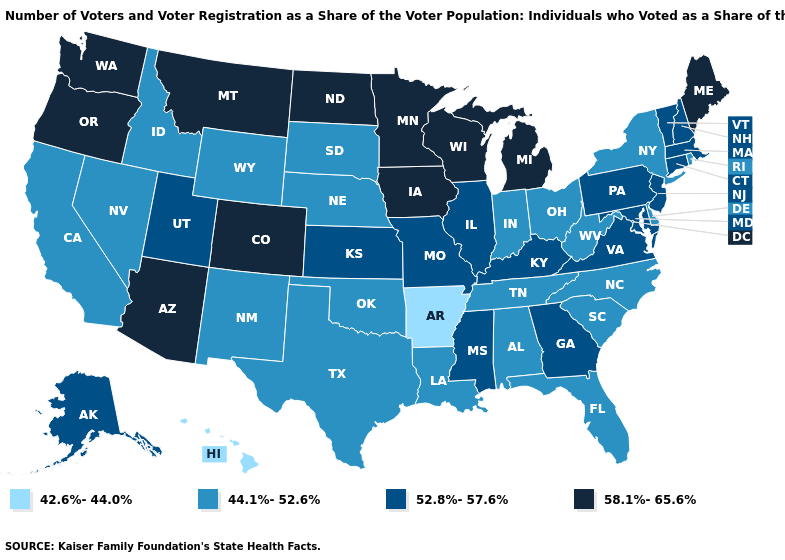What is the value of Pennsylvania?
Keep it brief. 52.8%-57.6%. Does Rhode Island have the same value as New Mexico?
Be succinct. Yes. Does Colorado have a lower value than Nevada?
Short answer required. No. Name the states that have a value in the range 52.8%-57.6%?
Quick response, please. Alaska, Connecticut, Georgia, Illinois, Kansas, Kentucky, Maryland, Massachusetts, Mississippi, Missouri, New Hampshire, New Jersey, Pennsylvania, Utah, Vermont, Virginia. Among the states that border Georgia , which have the lowest value?
Be succinct. Alabama, Florida, North Carolina, South Carolina, Tennessee. Which states have the highest value in the USA?
Be succinct. Arizona, Colorado, Iowa, Maine, Michigan, Minnesota, Montana, North Dakota, Oregon, Washington, Wisconsin. Name the states that have a value in the range 58.1%-65.6%?
Keep it brief. Arizona, Colorado, Iowa, Maine, Michigan, Minnesota, Montana, North Dakota, Oregon, Washington, Wisconsin. What is the value of Connecticut?
Answer briefly. 52.8%-57.6%. Does Virginia have the highest value in the South?
Short answer required. Yes. Among the states that border Missouri , does Arkansas have the highest value?
Keep it brief. No. What is the value of Wisconsin?
Be succinct. 58.1%-65.6%. Which states have the highest value in the USA?
Be succinct. Arizona, Colorado, Iowa, Maine, Michigan, Minnesota, Montana, North Dakota, Oregon, Washington, Wisconsin. Among the states that border Arkansas , does Texas have the lowest value?
Be succinct. Yes. Does Vermont have a lower value than Virginia?
Write a very short answer. No. Among the states that border Wyoming , does Montana have the lowest value?
Answer briefly. No. 